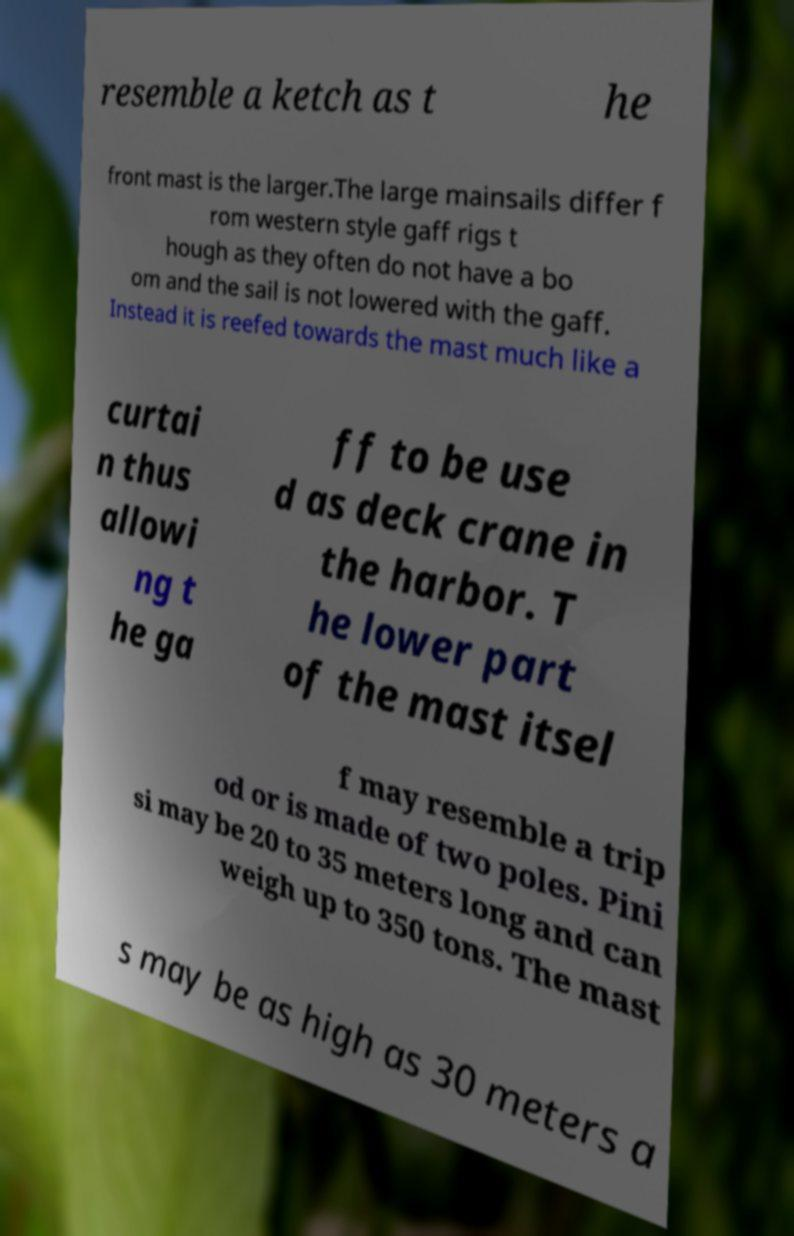Please read and relay the text visible in this image. What does it say? resemble a ketch as t he front mast is the larger.The large mainsails differ f rom western style gaff rigs t hough as they often do not have a bo om and the sail is not lowered with the gaff. Instead it is reefed towards the mast much like a curtai n thus allowi ng t he ga ff to be use d as deck crane in the harbor. T he lower part of the mast itsel f may resemble a trip od or is made of two poles. Pini si may be 20 to 35 meters long and can weigh up to 350 tons. The mast s may be as high as 30 meters a 